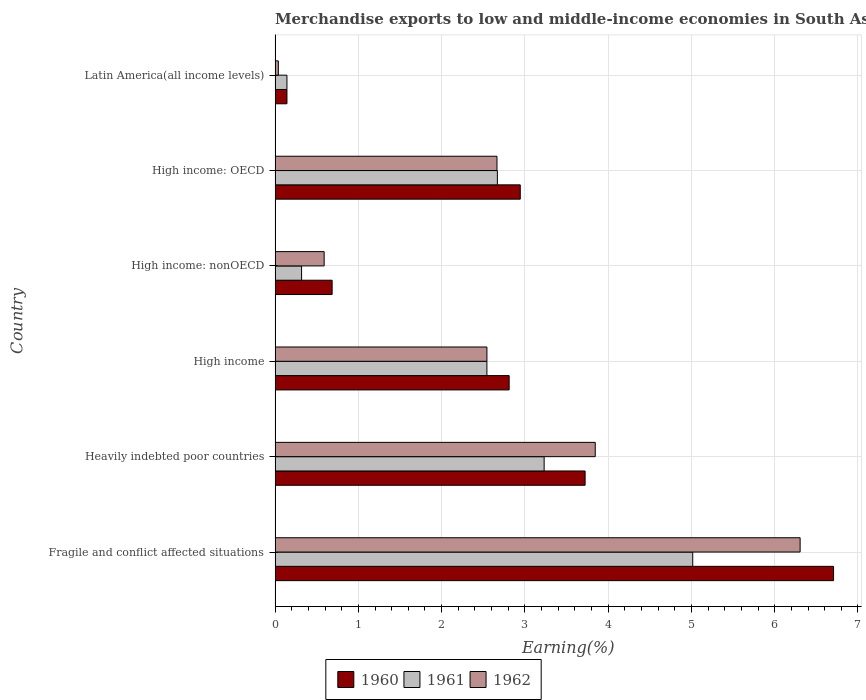How many groups of bars are there?
Make the answer very short. 6. Are the number of bars per tick equal to the number of legend labels?
Ensure brevity in your answer.  Yes. How many bars are there on the 5th tick from the top?
Give a very brief answer. 3. How many bars are there on the 1st tick from the bottom?
Offer a terse response. 3. What is the label of the 2nd group of bars from the top?
Offer a very short reply. High income: OECD. What is the percentage of amount earned from merchandise exports in 1961 in High income?
Make the answer very short. 2.54. Across all countries, what is the maximum percentage of amount earned from merchandise exports in 1960?
Provide a short and direct response. 6.71. Across all countries, what is the minimum percentage of amount earned from merchandise exports in 1961?
Offer a terse response. 0.14. In which country was the percentage of amount earned from merchandise exports in 1962 maximum?
Your answer should be compact. Fragile and conflict affected situations. In which country was the percentage of amount earned from merchandise exports in 1962 minimum?
Provide a short and direct response. Latin America(all income levels). What is the total percentage of amount earned from merchandise exports in 1962 in the graph?
Provide a short and direct response. 15.99. What is the difference between the percentage of amount earned from merchandise exports in 1961 in Fragile and conflict affected situations and that in Heavily indebted poor countries?
Your answer should be compact. 1.78. What is the difference between the percentage of amount earned from merchandise exports in 1961 in Fragile and conflict affected situations and the percentage of amount earned from merchandise exports in 1962 in High income: nonOECD?
Your response must be concise. 4.43. What is the average percentage of amount earned from merchandise exports in 1962 per country?
Make the answer very short. 2.66. What is the difference between the percentage of amount earned from merchandise exports in 1961 and percentage of amount earned from merchandise exports in 1960 in Latin America(all income levels)?
Make the answer very short. -0. In how many countries, is the percentage of amount earned from merchandise exports in 1960 greater than 4.6 %?
Offer a very short reply. 1. What is the ratio of the percentage of amount earned from merchandise exports in 1962 in Fragile and conflict affected situations to that in Latin America(all income levels)?
Your answer should be compact. 160.34. Is the percentage of amount earned from merchandise exports in 1962 in Fragile and conflict affected situations less than that in High income?
Your answer should be very brief. No. What is the difference between the highest and the second highest percentage of amount earned from merchandise exports in 1962?
Your answer should be compact. 2.46. What is the difference between the highest and the lowest percentage of amount earned from merchandise exports in 1960?
Provide a short and direct response. 6.56. In how many countries, is the percentage of amount earned from merchandise exports in 1961 greater than the average percentage of amount earned from merchandise exports in 1961 taken over all countries?
Your response must be concise. 4. What does the 1st bar from the top in Heavily indebted poor countries represents?
Make the answer very short. 1962. What does the 2nd bar from the bottom in High income: OECD represents?
Your answer should be compact. 1961. Is it the case that in every country, the sum of the percentage of amount earned from merchandise exports in 1961 and percentage of amount earned from merchandise exports in 1960 is greater than the percentage of amount earned from merchandise exports in 1962?
Provide a succinct answer. Yes. How many bars are there?
Your response must be concise. 18. How many countries are there in the graph?
Your response must be concise. 6. What is the difference between two consecutive major ticks on the X-axis?
Ensure brevity in your answer.  1. Does the graph contain any zero values?
Ensure brevity in your answer.  No. How many legend labels are there?
Provide a succinct answer. 3. What is the title of the graph?
Your response must be concise. Merchandise exports to low and middle-income economies in South Asia. What is the label or title of the X-axis?
Offer a terse response. Earning(%). What is the label or title of the Y-axis?
Provide a short and direct response. Country. What is the Earning(%) in 1960 in Fragile and conflict affected situations?
Offer a terse response. 6.71. What is the Earning(%) in 1961 in Fragile and conflict affected situations?
Offer a terse response. 5.02. What is the Earning(%) in 1962 in Fragile and conflict affected situations?
Make the answer very short. 6.31. What is the Earning(%) in 1960 in Heavily indebted poor countries?
Your response must be concise. 3.72. What is the Earning(%) in 1961 in Heavily indebted poor countries?
Your answer should be very brief. 3.23. What is the Earning(%) of 1962 in Heavily indebted poor countries?
Give a very brief answer. 3.84. What is the Earning(%) of 1960 in High income?
Your answer should be very brief. 2.81. What is the Earning(%) in 1961 in High income?
Provide a succinct answer. 2.54. What is the Earning(%) in 1962 in High income?
Ensure brevity in your answer.  2.54. What is the Earning(%) in 1960 in High income: nonOECD?
Make the answer very short. 0.69. What is the Earning(%) in 1961 in High income: nonOECD?
Offer a terse response. 0.32. What is the Earning(%) in 1962 in High income: nonOECD?
Your answer should be compact. 0.59. What is the Earning(%) in 1960 in High income: OECD?
Your response must be concise. 2.94. What is the Earning(%) in 1961 in High income: OECD?
Give a very brief answer. 2.67. What is the Earning(%) in 1962 in High income: OECD?
Offer a very short reply. 2.66. What is the Earning(%) of 1960 in Latin America(all income levels)?
Make the answer very short. 0.14. What is the Earning(%) in 1961 in Latin America(all income levels)?
Offer a very short reply. 0.14. What is the Earning(%) in 1962 in Latin America(all income levels)?
Offer a terse response. 0.04. Across all countries, what is the maximum Earning(%) in 1960?
Provide a short and direct response. 6.71. Across all countries, what is the maximum Earning(%) of 1961?
Provide a short and direct response. 5.02. Across all countries, what is the maximum Earning(%) in 1962?
Offer a terse response. 6.31. Across all countries, what is the minimum Earning(%) of 1960?
Your response must be concise. 0.14. Across all countries, what is the minimum Earning(%) in 1961?
Provide a succinct answer. 0.14. Across all countries, what is the minimum Earning(%) in 1962?
Your answer should be compact. 0.04. What is the total Earning(%) of 1960 in the graph?
Offer a very short reply. 17.01. What is the total Earning(%) in 1961 in the graph?
Your answer should be very brief. 13.92. What is the total Earning(%) of 1962 in the graph?
Your answer should be compact. 15.99. What is the difference between the Earning(%) in 1960 in Fragile and conflict affected situations and that in Heavily indebted poor countries?
Offer a terse response. 2.98. What is the difference between the Earning(%) of 1961 in Fragile and conflict affected situations and that in Heavily indebted poor countries?
Offer a very short reply. 1.78. What is the difference between the Earning(%) in 1962 in Fragile and conflict affected situations and that in Heavily indebted poor countries?
Offer a terse response. 2.46. What is the difference between the Earning(%) of 1960 in Fragile and conflict affected situations and that in High income?
Make the answer very short. 3.9. What is the difference between the Earning(%) of 1961 in Fragile and conflict affected situations and that in High income?
Offer a very short reply. 2.47. What is the difference between the Earning(%) in 1962 in Fragile and conflict affected situations and that in High income?
Make the answer very short. 3.76. What is the difference between the Earning(%) in 1960 in Fragile and conflict affected situations and that in High income: nonOECD?
Keep it short and to the point. 6.02. What is the difference between the Earning(%) in 1961 in Fragile and conflict affected situations and that in High income: nonOECD?
Offer a very short reply. 4.7. What is the difference between the Earning(%) in 1962 in Fragile and conflict affected situations and that in High income: nonOECD?
Ensure brevity in your answer.  5.72. What is the difference between the Earning(%) in 1960 in Fragile and conflict affected situations and that in High income: OECD?
Offer a very short reply. 3.76. What is the difference between the Earning(%) of 1961 in Fragile and conflict affected situations and that in High income: OECD?
Ensure brevity in your answer.  2.35. What is the difference between the Earning(%) in 1962 in Fragile and conflict affected situations and that in High income: OECD?
Provide a succinct answer. 3.64. What is the difference between the Earning(%) of 1960 in Fragile and conflict affected situations and that in Latin America(all income levels)?
Offer a very short reply. 6.56. What is the difference between the Earning(%) in 1961 in Fragile and conflict affected situations and that in Latin America(all income levels)?
Provide a succinct answer. 4.87. What is the difference between the Earning(%) in 1962 in Fragile and conflict affected situations and that in Latin America(all income levels)?
Your answer should be very brief. 6.27. What is the difference between the Earning(%) in 1960 in Heavily indebted poor countries and that in High income?
Offer a terse response. 0.91. What is the difference between the Earning(%) of 1961 in Heavily indebted poor countries and that in High income?
Your response must be concise. 0.69. What is the difference between the Earning(%) in 1962 in Heavily indebted poor countries and that in High income?
Your response must be concise. 1.3. What is the difference between the Earning(%) in 1960 in Heavily indebted poor countries and that in High income: nonOECD?
Keep it short and to the point. 3.04. What is the difference between the Earning(%) of 1961 in Heavily indebted poor countries and that in High income: nonOECD?
Offer a very short reply. 2.91. What is the difference between the Earning(%) in 1962 in Heavily indebted poor countries and that in High income: nonOECD?
Your answer should be very brief. 3.26. What is the difference between the Earning(%) of 1960 in Heavily indebted poor countries and that in High income: OECD?
Offer a terse response. 0.78. What is the difference between the Earning(%) in 1961 in Heavily indebted poor countries and that in High income: OECD?
Offer a terse response. 0.56. What is the difference between the Earning(%) in 1962 in Heavily indebted poor countries and that in High income: OECD?
Ensure brevity in your answer.  1.18. What is the difference between the Earning(%) in 1960 in Heavily indebted poor countries and that in Latin America(all income levels)?
Keep it short and to the point. 3.58. What is the difference between the Earning(%) in 1961 in Heavily indebted poor countries and that in Latin America(all income levels)?
Provide a short and direct response. 3.09. What is the difference between the Earning(%) of 1962 in Heavily indebted poor countries and that in Latin America(all income levels)?
Make the answer very short. 3.81. What is the difference between the Earning(%) of 1960 in High income and that in High income: nonOECD?
Give a very brief answer. 2.13. What is the difference between the Earning(%) of 1961 in High income and that in High income: nonOECD?
Offer a terse response. 2.23. What is the difference between the Earning(%) in 1962 in High income and that in High income: nonOECD?
Your response must be concise. 1.95. What is the difference between the Earning(%) of 1960 in High income and that in High income: OECD?
Your answer should be compact. -0.13. What is the difference between the Earning(%) of 1961 in High income and that in High income: OECD?
Your answer should be very brief. -0.13. What is the difference between the Earning(%) in 1962 in High income and that in High income: OECD?
Keep it short and to the point. -0.12. What is the difference between the Earning(%) in 1960 in High income and that in Latin America(all income levels)?
Provide a succinct answer. 2.67. What is the difference between the Earning(%) of 1961 in High income and that in Latin America(all income levels)?
Give a very brief answer. 2.4. What is the difference between the Earning(%) of 1962 in High income and that in Latin America(all income levels)?
Your answer should be compact. 2.5. What is the difference between the Earning(%) of 1960 in High income: nonOECD and that in High income: OECD?
Your answer should be compact. -2.26. What is the difference between the Earning(%) of 1961 in High income: nonOECD and that in High income: OECD?
Ensure brevity in your answer.  -2.35. What is the difference between the Earning(%) in 1962 in High income: nonOECD and that in High income: OECD?
Offer a very short reply. -2.08. What is the difference between the Earning(%) in 1960 in High income: nonOECD and that in Latin America(all income levels)?
Ensure brevity in your answer.  0.54. What is the difference between the Earning(%) of 1961 in High income: nonOECD and that in Latin America(all income levels)?
Make the answer very short. 0.18. What is the difference between the Earning(%) of 1962 in High income: nonOECD and that in Latin America(all income levels)?
Offer a terse response. 0.55. What is the difference between the Earning(%) of 1960 in High income: OECD and that in Latin America(all income levels)?
Ensure brevity in your answer.  2.8. What is the difference between the Earning(%) in 1961 in High income: OECD and that in Latin America(all income levels)?
Offer a terse response. 2.53. What is the difference between the Earning(%) in 1962 in High income: OECD and that in Latin America(all income levels)?
Offer a very short reply. 2.63. What is the difference between the Earning(%) in 1960 in Fragile and conflict affected situations and the Earning(%) in 1961 in Heavily indebted poor countries?
Your response must be concise. 3.48. What is the difference between the Earning(%) of 1960 in Fragile and conflict affected situations and the Earning(%) of 1962 in Heavily indebted poor countries?
Provide a succinct answer. 2.86. What is the difference between the Earning(%) in 1961 in Fragile and conflict affected situations and the Earning(%) in 1962 in Heavily indebted poor countries?
Provide a succinct answer. 1.17. What is the difference between the Earning(%) of 1960 in Fragile and conflict affected situations and the Earning(%) of 1961 in High income?
Give a very brief answer. 4.16. What is the difference between the Earning(%) in 1960 in Fragile and conflict affected situations and the Earning(%) in 1962 in High income?
Your answer should be very brief. 4.16. What is the difference between the Earning(%) in 1961 in Fragile and conflict affected situations and the Earning(%) in 1962 in High income?
Your answer should be compact. 2.47. What is the difference between the Earning(%) in 1960 in Fragile and conflict affected situations and the Earning(%) in 1961 in High income: nonOECD?
Ensure brevity in your answer.  6.39. What is the difference between the Earning(%) in 1960 in Fragile and conflict affected situations and the Earning(%) in 1962 in High income: nonOECD?
Keep it short and to the point. 6.12. What is the difference between the Earning(%) in 1961 in Fragile and conflict affected situations and the Earning(%) in 1962 in High income: nonOECD?
Give a very brief answer. 4.43. What is the difference between the Earning(%) of 1960 in Fragile and conflict affected situations and the Earning(%) of 1961 in High income: OECD?
Your response must be concise. 4.04. What is the difference between the Earning(%) in 1960 in Fragile and conflict affected situations and the Earning(%) in 1962 in High income: OECD?
Provide a short and direct response. 4.04. What is the difference between the Earning(%) in 1961 in Fragile and conflict affected situations and the Earning(%) in 1962 in High income: OECD?
Offer a terse response. 2.35. What is the difference between the Earning(%) of 1960 in Fragile and conflict affected situations and the Earning(%) of 1961 in Latin America(all income levels)?
Offer a very short reply. 6.56. What is the difference between the Earning(%) of 1960 in Fragile and conflict affected situations and the Earning(%) of 1962 in Latin America(all income levels)?
Offer a terse response. 6.67. What is the difference between the Earning(%) in 1961 in Fragile and conflict affected situations and the Earning(%) in 1962 in Latin America(all income levels)?
Ensure brevity in your answer.  4.98. What is the difference between the Earning(%) of 1960 in Heavily indebted poor countries and the Earning(%) of 1961 in High income?
Offer a very short reply. 1.18. What is the difference between the Earning(%) in 1960 in Heavily indebted poor countries and the Earning(%) in 1962 in High income?
Offer a terse response. 1.18. What is the difference between the Earning(%) in 1961 in Heavily indebted poor countries and the Earning(%) in 1962 in High income?
Your answer should be very brief. 0.69. What is the difference between the Earning(%) of 1960 in Heavily indebted poor countries and the Earning(%) of 1961 in High income: nonOECD?
Your answer should be compact. 3.4. What is the difference between the Earning(%) in 1960 in Heavily indebted poor countries and the Earning(%) in 1962 in High income: nonOECD?
Offer a very short reply. 3.13. What is the difference between the Earning(%) in 1961 in Heavily indebted poor countries and the Earning(%) in 1962 in High income: nonOECD?
Give a very brief answer. 2.64. What is the difference between the Earning(%) of 1960 in Heavily indebted poor countries and the Earning(%) of 1961 in High income: OECD?
Give a very brief answer. 1.05. What is the difference between the Earning(%) in 1960 in Heavily indebted poor countries and the Earning(%) in 1962 in High income: OECD?
Make the answer very short. 1.06. What is the difference between the Earning(%) of 1961 in Heavily indebted poor countries and the Earning(%) of 1962 in High income: OECD?
Keep it short and to the point. 0.57. What is the difference between the Earning(%) of 1960 in Heavily indebted poor countries and the Earning(%) of 1961 in Latin America(all income levels)?
Your answer should be very brief. 3.58. What is the difference between the Earning(%) of 1960 in Heavily indebted poor countries and the Earning(%) of 1962 in Latin America(all income levels)?
Provide a short and direct response. 3.68. What is the difference between the Earning(%) of 1961 in Heavily indebted poor countries and the Earning(%) of 1962 in Latin America(all income levels)?
Provide a short and direct response. 3.19. What is the difference between the Earning(%) in 1960 in High income and the Earning(%) in 1961 in High income: nonOECD?
Offer a very short reply. 2.49. What is the difference between the Earning(%) of 1960 in High income and the Earning(%) of 1962 in High income: nonOECD?
Keep it short and to the point. 2.22. What is the difference between the Earning(%) of 1961 in High income and the Earning(%) of 1962 in High income: nonOECD?
Your response must be concise. 1.95. What is the difference between the Earning(%) in 1960 in High income and the Earning(%) in 1961 in High income: OECD?
Offer a terse response. 0.14. What is the difference between the Earning(%) of 1960 in High income and the Earning(%) of 1962 in High income: OECD?
Give a very brief answer. 0.15. What is the difference between the Earning(%) of 1961 in High income and the Earning(%) of 1962 in High income: OECD?
Give a very brief answer. -0.12. What is the difference between the Earning(%) in 1960 in High income and the Earning(%) in 1961 in Latin America(all income levels)?
Your answer should be very brief. 2.67. What is the difference between the Earning(%) in 1960 in High income and the Earning(%) in 1962 in Latin America(all income levels)?
Give a very brief answer. 2.77. What is the difference between the Earning(%) of 1961 in High income and the Earning(%) of 1962 in Latin America(all income levels)?
Keep it short and to the point. 2.5. What is the difference between the Earning(%) of 1960 in High income: nonOECD and the Earning(%) of 1961 in High income: OECD?
Make the answer very short. -1.98. What is the difference between the Earning(%) in 1960 in High income: nonOECD and the Earning(%) in 1962 in High income: OECD?
Ensure brevity in your answer.  -1.98. What is the difference between the Earning(%) of 1961 in High income: nonOECD and the Earning(%) of 1962 in High income: OECD?
Your answer should be very brief. -2.35. What is the difference between the Earning(%) of 1960 in High income: nonOECD and the Earning(%) of 1961 in Latin America(all income levels)?
Give a very brief answer. 0.54. What is the difference between the Earning(%) of 1960 in High income: nonOECD and the Earning(%) of 1962 in Latin America(all income levels)?
Give a very brief answer. 0.65. What is the difference between the Earning(%) of 1961 in High income: nonOECD and the Earning(%) of 1962 in Latin America(all income levels)?
Give a very brief answer. 0.28. What is the difference between the Earning(%) of 1960 in High income: OECD and the Earning(%) of 1961 in Latin America(all income levels)?
Offer a terse response. 2.8. What is the difference between the Earning(%) in 1960 in High income: OECD and the Earning(%) in 1962 in Latin America(all income levels)?
Your answer should be very brief. 2.91. What is the difference between the Earning(%) in 1961 in High income: OECD and the Earning(%) in 1962 in Latin America(all income levels)?
Your response must be concise. 2.63. What is the average Earning(%) of 1960 per country?
Offer a terse response. 2.84. What is the average Earning(%) of 1961 per country?
Give a very brief answer. 2.32. What is the average Earning(%) of 1962 per country?
Offer a terse response. 2.66. What is the difference between the Earning(%) of 1960 and Earning(%) of 1961 in Fragile and conflict affected situations?
Your answer should be very brief. 1.69. What is the difference between the Earning(%) in 1960 and Earning(%) in 1962 in Fragile and conflict affected situations?
Provide a short and direct response. 0.4. What is the difference between the Earning(%) in 1961 and Earning(%) in 1962 in Fragile and conflict affected situations?
Keep it short and to the point. -1.29. What is the difference between the Earning(%) of 1960 and Earning(%) of 1961 in Heavily indebted poor countries?
Offer a terse response. 0.49. What is the difference between the Earning(%) in 1960 and Earning(%) in 1962 in Heavily indebted poor countries?
Ensure brevity in your answer.  -0.12. What is the difference between the Earning(%) in 1961 and Earning(%) in 1962 in Heavily indebted poor countries?
Make the answer very short. -0.61. What is the difference between the Earning(%) of 1960 and Earning(%) of 1961 in High income?
Provide a short and direct response. 0.27. What is the difference between the Earning(%) in 1960 and Earning(%) in 1962 in High income?
Offer a very short reply. 0.27. What is the difference between the Earning(%) of 1961 and Earning(%) of 1962 in High income?
Your response must be concise. -0. What is the difference between the Earning(%) of 1960 and Earning(%) of 1961 in High income: nonOECD?
Provide a succinct answer. 0.37. What is the difference between the Earning(%) of 1960 and Earning(%) of 1962 in High income: nonOECD?
Offer a terse response. 0.1. What is the difference between the Earning(%) of 1961 and Earning(%) of 1962 in High income: nonOECD?
Provide a short and direct response. -0.27. What is the difference between the Earning(%) in 1960 and Earning(%) in 1961 in High income: OECD?
Provide a short and direct response. 0.27. What is the difference between the Earning(%) in 1960 and Earning(%) in 1962 in High income: OECD?
Keep it short and to the point. 0.28. What is the difference between the Earning(%) of 1961 and Earning(%) of 1962 in High income: OECD?
Offer a very short reply. 0. What is the difference between the Earning(%) of 1960 and Earning(%) of 1961 in Latin America(all income levels)?
Offer a very short reply. 0. What is the difference between the Earning(%) in 1960 and Earning(%) in 1962 in Latin America(all income levels)?
Provide a short and direct response. 0.1. What is the difference between the Earning(%) in 1961 and Earning(%) in 1962 in Latin America(all income levels)?
Provide a short and direct response. 0.1. What is the ratio of the Earning(%) in 1960 in Fragile and conflict affected situations to that in Heavily indebted poor countries?
Offer a very short reply. 1.8. What is the ratio of the Earning(%) of 1961 in Fragile and conflict affected situations to that in Heavily indebted poor countries?
Give a very brief answer. 1.55. What is the ratio of the Earning(%) in 1962 in Fragile and conflict affected situations to that in Heavily indebted poor countries?
Your response must be concise. 1.64. What is the ratio of the Earning(%) in 1960 in Fragile and conflict affected situations to that in High income?
Your answer should be compact. 2.39. What is the ratio of the Earning(%) of 1961 in Fragile and conflict affected situations to that in High income?
Keep it short and to the point. 1.97. What is the ratio of the Earning(%) in 1962 in Fragile and conflict affected situations to that in High income?
Give a very brief answer. 2.48. What is the ratio of the Earning(%) of 1960 in Fragile and conflict affected situations to that in High income: nonOECD?
Your answer should be very brief. 9.79. What is the ratio of the Earning(%) in 1961 in Fragile and conflict affected situations to that in High income: nonOECD?
Provide a short and direct response. 15.76. What is the ratio of the Earning(%) in 1962 in Fragile and conflict affected situations to that in High income: nonOECD?
Your response must be concise. 10.7. What is the ratio of the Earning(%) of 1960 in Fragile and conflict affected situations to that in High income: OECD?
Offer a very short reply. 2.28. What is the ratio of the Earning(%) of 1961 in Fragile and conflict affected situations to that in High income: OECD?
Provide a short and direct response. 1.88. What is the ratio of the Earning(%) in 1962 in Fragile and conflict affected situations to that in High income: OECD?
Your answer should be very brief. 2.37. What is the ratio of the Earning(%) in 1960 in Fragile and conflict affected situations to that in Latin America(all income levels)?
Your answer should be compact. 47.01. What is the ratio of the Earning(%) of 1961 in Fragile and conflict affected situations to that in Latin America(all income levels)?
Offer a terse response. 35.21. What is the ratio of the Earning(%) of 1962 in Fragile and conflict affected situations to that in Latin America(all income levels)?
Provide a short and direct response. 160.34. What is the ratio of the Earning(%) of 1960 in Heavily indebted poor countries to that in High income?
Your answer should be compact. 1.32. What is the ratio of the Earning(%) of 1961 in Heavily indebted poor countries to that in High income?
Your answer should be very brief. 1.27. What is the ratio of the Earning(%) in 1962 in Heavily indebted poor countries to that in High income?
Give a very brief answer. 1.51. What is the ratio of the Earning(%) in 1960 in Heavily indebted poor countries to that in High income: nonOECD?
Offer a very short reply. 5.43. What is the ratio of the Earning(%) of 1961 in Heavily indebted poor countries to that in High income: nonOECD?
Ensure brevity in your answer.  10.16. What is the ratio of the Earning(%) in 1962 in Heavily indebted poor countries to that in High income: nonOECD?
Your response must be concise. 6.52. What is the ratio of the Earning(%) of 1960 in Heavily indebted poor countries to that in High income: OECD?
Provide a succinct answer. 1.26. What is the ratio of the Earning(%) in 1961 in Heavily indebted poor countries to that in High income: OECD?
Offer a terse response. 1.21. What is the ratio of the Earning(%) in 1962 in Heavily indebted poor countries to that in High income: OECD?
Your response must be concise. 1.44. What is the ratio of the Earning(%) in 1960 in Heavily indebted poor countries to that in Latin America(all income levels)?
Offer a very short reply. 26.1. What is the ratio of the Earning(%) of 1961 in Heavily indebted poor countries to that in Latin America(all income levels)?
Make the answer very short. 22.68. What is the ratio of the Earning(%) in 1962 in Heavily indebted poor countries to that in Latin America(all income levels)?
Your answer should be compact. 97.78. What is the ratio of the Earning(%) in 1960 in High income to that in High income: nonOECD?
Offer a terse response. 4.1. What is the ratio of the Earning(%) of 1961 in High income to that in High income: nonOECD?
Make the answer very short. 8. What is the ratio of the Earning(%) of 1962 in High income to that in High income: nonOECD?
Ensure brevity in your answer.  4.32. What is the ratio of the Earning(%) in 1960 in High income to that in High income: OECD?
Give a very brief answer. 0.95. What is the ratio of the Earning(%) in 1961 in High income to that in High income: OECD?
Ensure brevity in your answer.  0.95. What is the ratio of the Earning(%) in 1962 in High income to that in High income: OECD?
Ensure brevity in your answer.  0.95. What is the ratio of the Earning(%) of 1960 in High income to that in Latin America(all income levels)?
Ensure brevity in your answer.  19.7. What is the ratio of the Earning(%) in 1961 in High income to that in Latin America(all income levels)?
Your answer should be very brief. 17.86. What is the ratio of the Earning(%) in 1962 in High income to that in Latin America(all income levels)?
Ensure brevity in your answer.  64.69. What is the ratio of the Earning(%) of 1960 in High income: nonOECD to that in High income: OECD?
Keep it short and to the point. 0.23. What is the ratio of the Earning(%) in 1961 in High income: nonOECD to that in High income: OECD?
Make the answer very short. 0.12. What is the ratio of the Earning(%) of 1962 in High income: nonOECD to that in High income: OECD?
Keep it short and to the point. 0.22. What is the ratio of the Earning(%) in 1960 in High income: nonOECD to that in Latin America(all income levels)?
Make the answer very short. 4.8. What is the ratio of the Earning(%) in 1961 in High income: nonOECD to that in Latin America(all income levels)?
Your answer should be very brief. 2.23. What is the ratio of the Earning(%) of 1962 in High income: nonOECD to that in Latin America(all income levels)?
Your response must be concise. 14.98. What is the ratio of the Earning(%) of 1960 in High income: OECD to that in Latin America(all income levels)?
Provide a short and direct response. 20.64. What is the ratio of the Earning(%) in 1961 in High income: OECD to that in Latin America(all income levels)?
Make the answer very short. 18.74. What is the ratio of the Earning(%) in 1962 in High income: OECD to that in Latin America(all income levels)?
Provide a short and direct response. 67.77. What is the difference between the highest and the second highest Earning(%) of 1960?
Offer a terse response. 2.98. What is the difference between the highest and the second highest Earning(%) of 1961?
Ensure brevity in your answer.  1.78. What is the difference between the highest and the second highest Earning(%) of 1962?
Ensure brevity in your answer.  2.46. What is the difference between the highest and the lowest Earning(%) of 1960?
Ensure brevity in your answer.  6.56. What is the difference between the highest and the lowest Earning(%) of 1961?
Provide a short and direct response. 4.87. What is the difference between the highest and the lowest Earning(%) of 1962?
Offer a terse response. 6.27. 